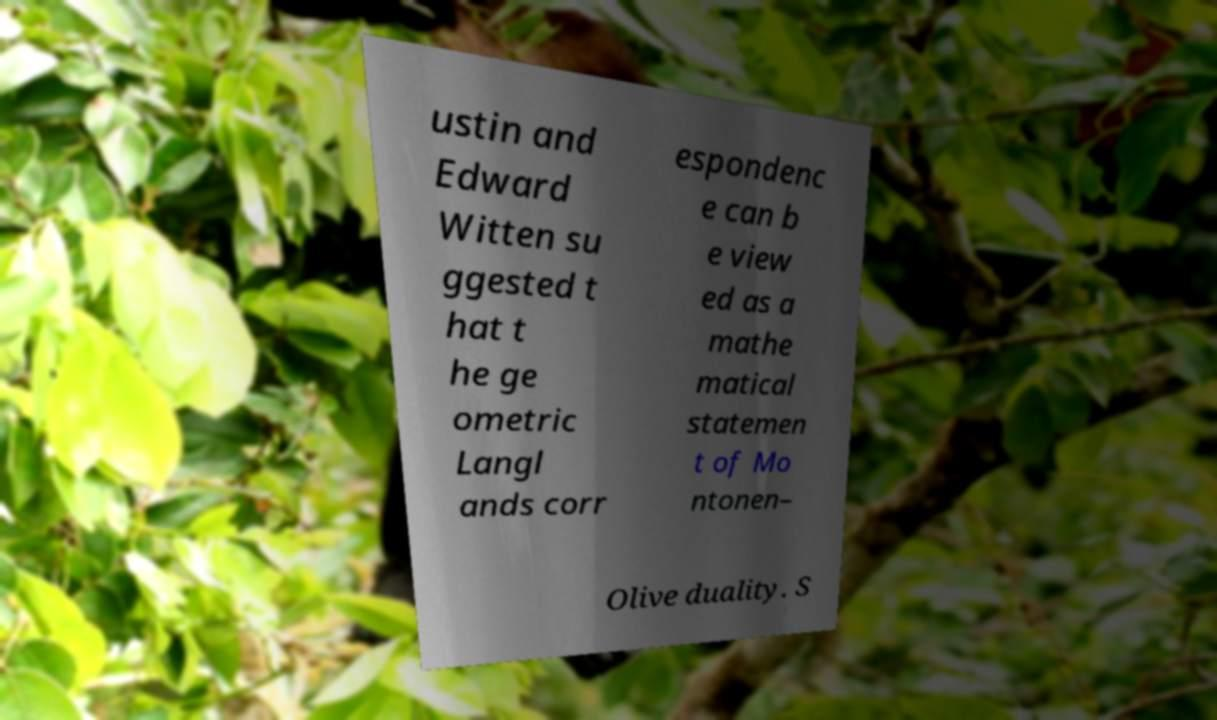What messages or text are displayed in this image? I need them in a readable, typed format. ustin and Edward Witten su ggested t hat t he ge ometric Langl ands corr espondenc e can b e view ed as a mathe matical statemen t of Mo ntonen– Olive duality. S 